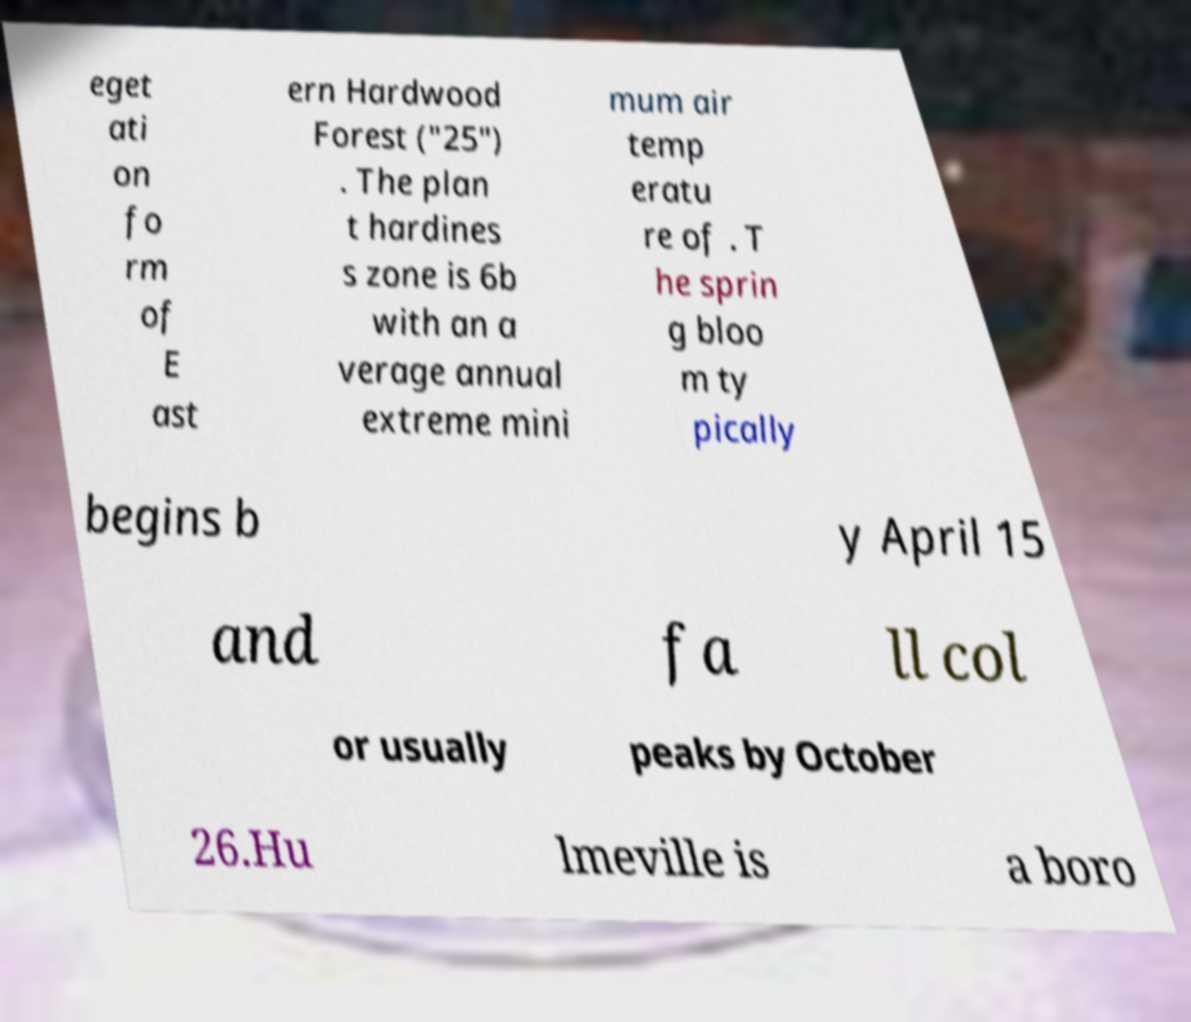Can you accurately transcribe the text from the provided image for me? eget ati on fo rm of E ast ern Hardwood Forest ("25") . The plan t hardines s zone is 6b with an a verage annual extreme mini mum air temp eratu re of . T he sprin g bloo m ty pically begins b y April 15 and fa ll col or usually peaks by October 26.Hu lmeville is a boro 